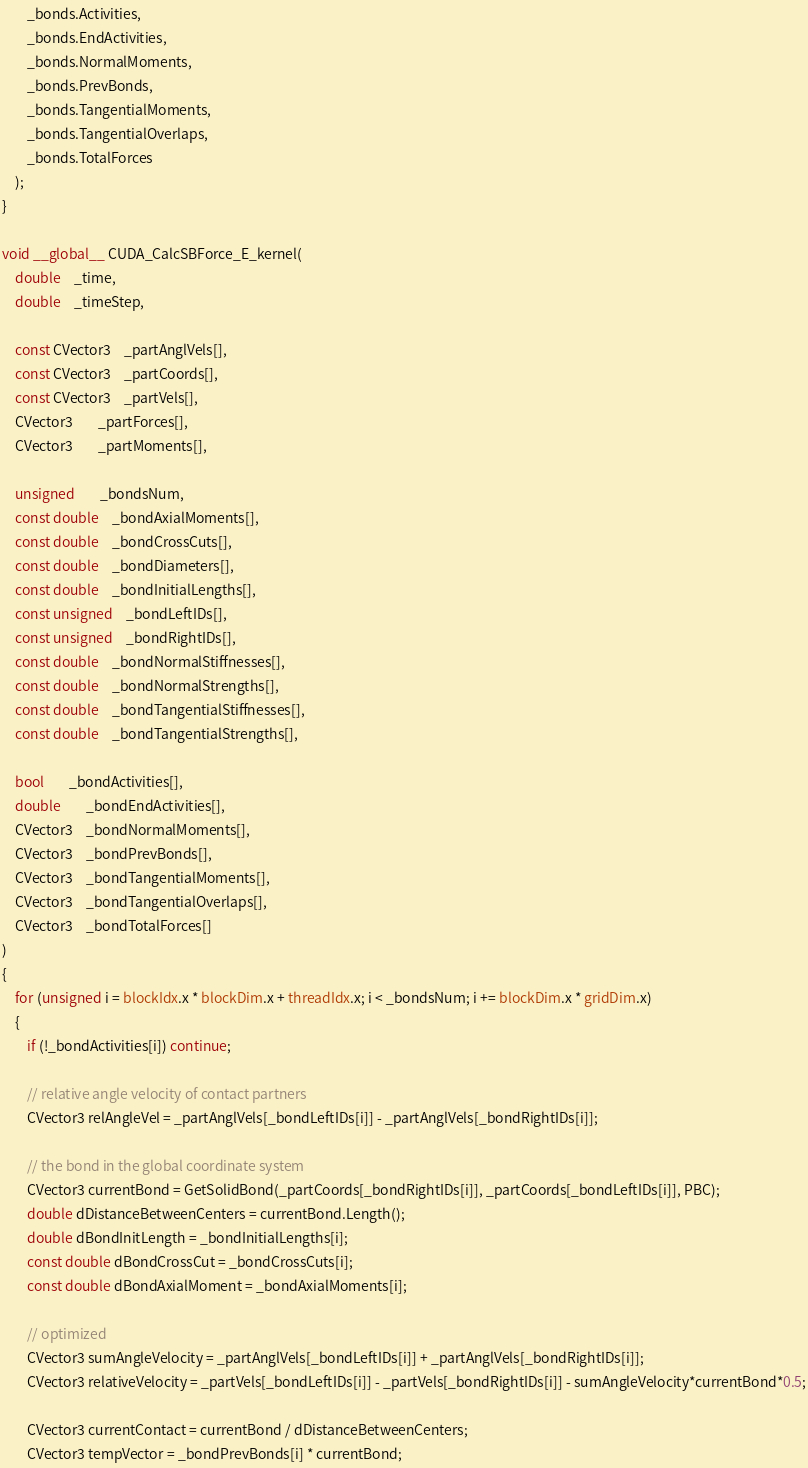Convert code to text. <code><loc_0><loc_0><loc_500><loc_500><_Cuda_>

		_bonds.Activities,
		_bonds.EndActivities,
		_bonds.NormalMoments,
		_bonds.PrevBonds,
		_bonds.TangentialMoments,
		_bonds.TangentialOverlaps,
		_bonds.TotalForces
	);
}

void __global__ CUDA_CalcSBForce_E_kernel(
	double	_time,
	double	_timeStep,

	const CVector3	_partAnglVels[],
	const CVector3	_partCoords[],
	const CVector3	_partVels[],
	CVector3		_partForces[],
	CVector3		_partMoments[],

	unsigned		_bondsNum,
	const double	_bondAxialMoments[],
	const double	_bondCrossCuts[],
	const double	_bondDiameters[],
	const double	_bondInitialLengths[],
	const unsigned	_bondLeftIDs[],
	const unsigned	_bondRightIDs[],
	const double	_bondNormalStiffnesses[],
	const double	_bondNormalStrengths[],
	const double	_bondTangentialStiffnesses[],
	const double	_bondTangentialStrengths[],

	bool		_bondActivities[],
	double		_bondEndActivities[],
	CVector3	_bondNormalMoments[],
	CVector3	_bondPrevBonds[],
	CVector3	_bondTangentialMoments[],
	CVector3	_bondTangentialOverlaps[],
	CVector3	_bondTotalForces[]
)
{
	for (unsigned i = blockIdx.x * blockDim.x + threadIdx.x; i < _bondsNum; i += blockDim.x * gridDim.x)
	{
		if (!_bondActivities[i]) continue;

		// relative angle velocity of contact partners
		CVector3 relAngleVel = _partAnglVels[_bondLeftIDs[i]] - _partAnglVels[_bondRightIDs[i]];

		// the bond in the global coordinate system
		CVector3 currentBond = GetSolidBond(_partCoords[_bondRightIDs[i]], _partCoords[_bondLeftIDs[i]], PBC);
		double dDistanceBetweenCenters = currentBond.Length();
		double dBondInitLength = _bondInitialLengths[i];
		const double dBondCrossCut = _bondCrossCuts[i];
		const double dBondAxialMoment = _bondAxialMoments[i];

		// optimized
		CVector3 sumAngleVelocity = _partAnglVels[_bondLeftIDs[i]] + _partAnglVels[_bondRightIDs[i]];
		CVector3 relativeVelocity = _partVels[_bondLeftIDs[i]] - _partVels[_bondRightIDs[i]] - sumAngleVelocity*currentBond*0.5;

		CVector3 currentContact = currentBond / dDistanceBetweenCenters;
		CVector3 tempVector = _bondPrevBonds[i] * currentBond;
</code> 